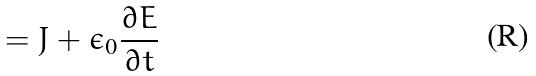<formula> <loc_0><loc_0><loc_500><loc_500>= J + \epsilon _ { 0 } \frac { \partial E } { \partial t }</formula> 